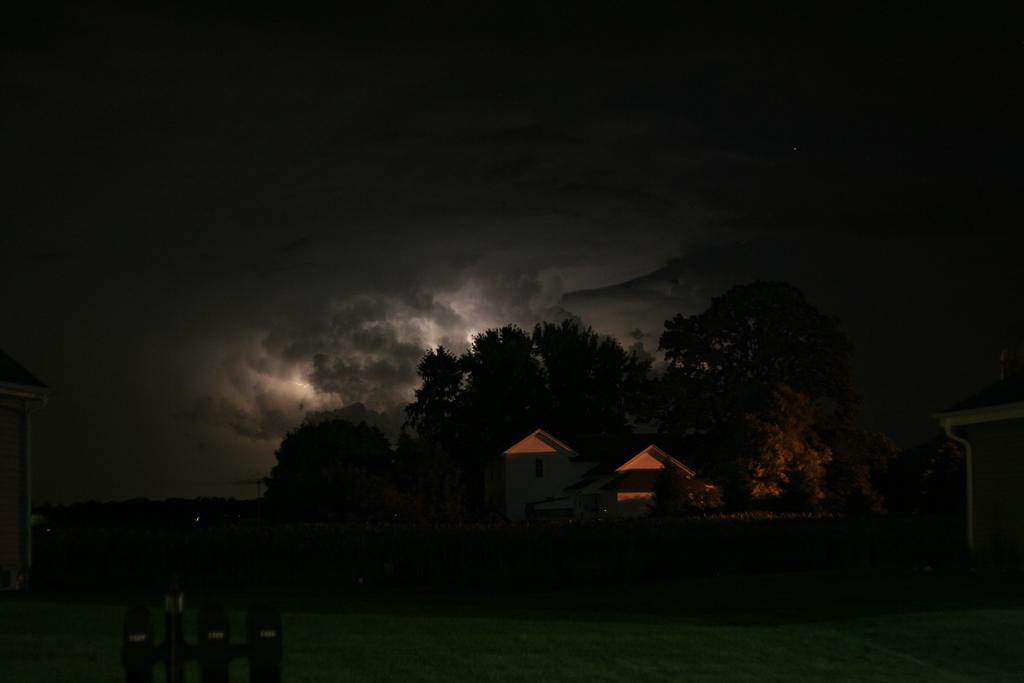What type of structure is in the image? There is a building in the image. What can be seen behind the building? Trees are visible behind the building. What is visible in the background of the image? The sky is visible in the background of the image. What can be observed in the sky? Clouds are present in the sky. Are there any other buildings in the image? Yes, there are buildings on the sides of the main building. What type of knowledge can be gained from the tree in the image? There is no tree present in the image that can provide knowledge; the image only features a building and its surroundings. 